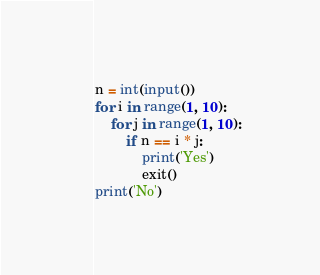<code> <loc_0><loc_0><loc_500><loc_500><_Python_>n = int(input())
for i in range(1, 10):
    for j in range(1, 10):
        if n == i * j:
            print('Yes')
            exit()
print('No')
</code> 